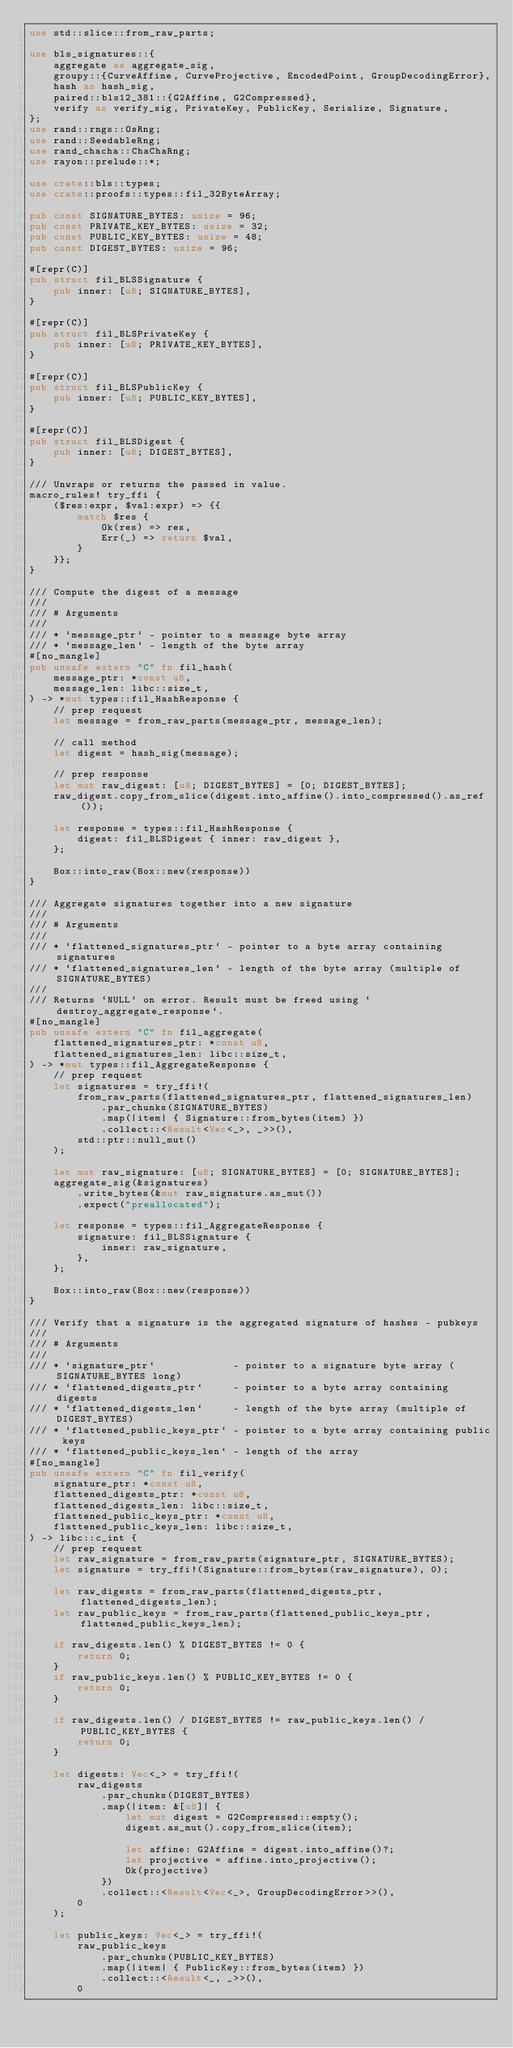Convert code to text. <code><loc_0><loc_0><loc_500><loc_500><_Rust_>use std::slice::from_raw_parts;

use bls_signatures::{
    aggregate as aggregate_sig,
    groupy::{CurveAffine, CurveProjective, EncodedPoint, GroupDecodingError},
    hash as hash_sig,
    paired::bls12_381::{G2Affine, G2Compressed},
    verify as verify_sig, PrivateKey, PublicKey, Serialize, Signature,
};
use rand::rngs::OsRng;
use rand::SeedableRng;
use rand_chacha::ChaChaRng;
use rayon::prelude::*;

use crate::bls::types;
use crate::proofs::types::fil_32ByteArray;

pub const SIGNATURE_BYTES: usize = 96;
pub const PRIVATE_KEY_BYTES: usize = 32;
pub const PUBLIC_KEY_BYTES: usize = 48;
pub const DIGEST_BYTES: usize = 96;

#[repr(C)]
pub struct fil_BLSSignature {
    pub inner: [u8; SIGNATURE_BYTES],
}

#[repr(C)]
pub struct fil_BLSPrivateKey {
    pub inner: [u8; PRIVATE_KEY_BYTES],
}

#[repr(C)]
pub struct fil_BLSPublicKey {
    pub inner: [u8; PUBLIC_KEY_BYTES],
}

#[repr(C)]
pub struct fil_BLSDigest {
    pub inner: [u8; DIGEST_BYTES],
}

/// Unwraps or returns the passed in value.
macro_rules! try_ffi {
    ($res:expr, $val:expr) => {{
        match $res {
            Ok(res) => res,
            Err(_) => return $val,
        }
    }};
}

/// Compute the digest of a message
///
/// # Arguments
///
/// * `message_ptr` - pointer to a message byte array
/// * `message_len` - length of the byte array
#[no_mangle]
pub unsafe extern "C" fn fil_hash(
    message_ptr: *const u8,
    message_len: libc::size_t,
) -> *mut types::fil_HashResponse {
    // prep request
    let message = from_raw_parts(message_ptr, message_len);

    // call method
    let digest = hash_sig(message);

    // prep response
    let mut raw_digest: [u8; DIGEST_BYTES] = [0; DIGEST_BYTES];
    raw_digest.copy_from_slice(digest.into_affine().into_compressed().as_ref());

    let response = types::fil_HashResponse {
        digest: fil_BLSDigest { inner: raw_digest },
    };

    Box::into_raw(Box::new(response))
}

/// Aggregate signatures together into a new signature
///
/// # Arguments
///
/// * `flattened_signatures_ptr` - pointer to a byte array containing signatures
/// * `flattened_signatures_len` - length of the byte array (multiple of SIGNATURE_BYTES)
///
/// Returns `NULL` on error. Result must be freed using `destroy_aggregate_response`.
#[no_mangle]
pub unsafe extern "C" fn fil_aggregate(
    flattened_signatures_ptr: *const u8,
    flattened_signatures_len: libc::size_t,
) -> *mut types::fil_AggregateResponse {
    // prep request
    let signatures = try_ffi!(
        from_raw_parts(flattened_signatures_ptr, flattened_signatures_len)
            .par_chunks(SIGNATURE_BYTES)
            .map(|item| { Signature::from_bytes(item) })
            .collect::<Result<Vec<_>, _>>(),
        std::ptr::null_mut()
    );

    let mut raw_signature: [u8; SIGNATURE_BYTES] = [0; SIGNATURE_BYTES];
    aggregate_sig(&signatures)
        .write_bytes(&mut raw_signature.as_mut())
        .expect("preallocated");

    let response = types::fil_AggregateResponse {
        signature: fil_BLSSignature {
            inner: raw_signature,
        },
    };

    Box::into_raw(Box::new(response))
}

/// Verify that a signature is the aggregated signature of hashes - pubkeys
///
/// # Arguments
///
/// * `signature_ptr`             - pointer to a signature byte array (SIGNATURE_BYTES long)
/// * `flattened_digests_ptr`     - pointer to a byte array containing digests
/// * `flattened_digests_len`     - length of the byte array (multiple of DIGEST_BYTES)
/// * `flattened_public_keys_ptr` - pointer to a byte array containing public keys
/// * `flattened_public_keys_len` - length of the array
#[no_mangle]
pub unsafe extern "C" fn fil_verify(
    signature_ptr: *const u8,
    flattened_digests_ptr: *const u8,
    flattened_digests_len: libc::size_t,
    flattened_public_keys_ptr: *const u8,
    flattened_public_keys_len: libc::size_t,
) -> libc::c_int {
    // prep request
    let raw_signature = from_raw_parts(signature_ptr, SIGNATURE_BYTES);
    let signature = try_ffi!(Signature::from_bytes(raw_signature), 0);

    let raw_digests = from_raw_parts(flattened_digests_ptr, flattened_digests_len);
    let raw_public_keys = from_raw_parts(flattened_public_keys_ptr, flattened_public_keys_len);

    if raw_digests.len() % DIGEST_BYTES != 0 {
        return 0;
    }
    if raw_public_keys.len() % PUBLIC_KEY_BYTES != 0 {
        return 0;
    }

    if raw_digests.len() / DIGEST_BYTES != raw_public_keys.len() / PUBLIC_KEY_BYTES {
        return 0;
    }

    let digests: Vec<_> = try_ffi!(
        raw_digests
            .par_chunks(DIGEST_BYTES)
            .map(|item: &[u8]| {
                let mut digest = G2Compressed::empty();
                digest.as_mut().copy_from_slice(item);

                let affine: G2Affine = digest.into_affine()?;
                let projective = affine.into_projective();
                Ok(projective)
            })
            .collect::<Result<Vec<_>, GroupDecodingError>>(),
        0
    );

    let public_keys: Vec<_> = try_ffi!(
        raw_public_keys
            .par_chunks(PUBLIC_KEY_BYTES)
            .map(|item| { PublicKey::from_bytes(item) })
            .collect::<Result<_, _>>(),
        0</code> 